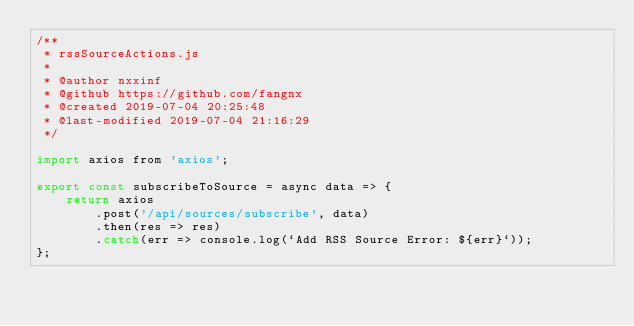<code> <loc_0><loc_0><loc_500><loc_500><_JavaScript_>/**
 * rssSourceActions.js
 *
 * @author nxxinf
 * @github https://github.com/fangnx
 * @created 2019-07-04 20:25:48
 * @last-modified 2019-07-04 21:16:29
 */

import axios from 'axios';

export const subscribeToSource = async data => {
	return axios
		.post('/api/sources/subscribe', data)
		.then(res => res)
		.catch(err => console.log(`Add RSS Source Error: ${err}`));
};
</code> 